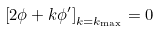Convert formula to latex. <formula><loc_0><loc_0><loc_500><loc_500>\left [ 2 \phi + k \phi ^ { \prime } \right ] _ { k = k _ { \max } } = 0</formula> 